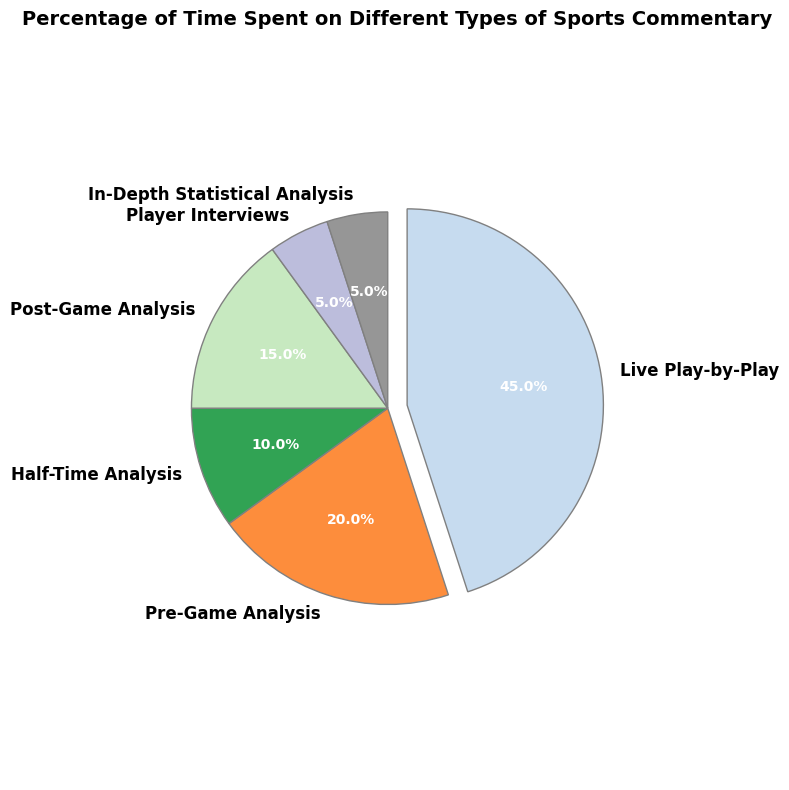What's the largest category by percentage? Look for the segment with the highest percentage on the pie chart, which is emphasized by an extra separation (explode).
Answer: Live Play-by-Play How much more time is spent on Live Play-by-Play compared to Half-Time Analysis? Identify the percentages of Live Play-by-Play and Half-Time Analysis from the pie chart. Subtract the two values: 45% - 10% = 35%.
Answer: 35% What is the combined percentage for Pre-Game Analysis and Post-Game Analysis? Add the percentages for Pre-Game Analysis and Post-Game Analysis from the chart. 20% + 15% = 35%.
Answer: 35% Which two categories have the smallest percentage and what is their total percentage? Identify the two smallest segments in the pie chart as Player Interviews and In-Depth Statistical Analysis, both at 5%. Add their percentages: 5% + 5% = 10%.
Answer: Player Interviews and In-Depth Statistical Analysis, 10% Is more time spent on Player Interviews or Half-Time Analysis? Compare the percentages of Player Interviews and Half-Time Analysis from the pie chart. Half-Time Analysis (10%) is more than Player Interviews (5%).
Answer: Half-Time Analysis What fraction of the total time is spent on Live Play-by-Play and Pre-Game Analysis together? Combine the percentages for Live Play-by-Play and Pre-Game Analysis. 45% + 20% = 65%. Therefore, the fraction is 65/100 = 0.65.
Answer: 0.65 What percentage of time is spent on analysis (Pre-Game, Half-Time, Post-Game)? Sum the percentages for Pre-Game Analysis, Half-Time Analysis, and Post-Game Analysis. 20% + 10% + 15% = 45%.
Answer: 45% What is the visual clue that helps in identifying the largest category in the pie chart? Notice that the largest segment is separated slightly from the rest of the pie, which is the explode effect.
Answer: The segment is separated (exploded) 